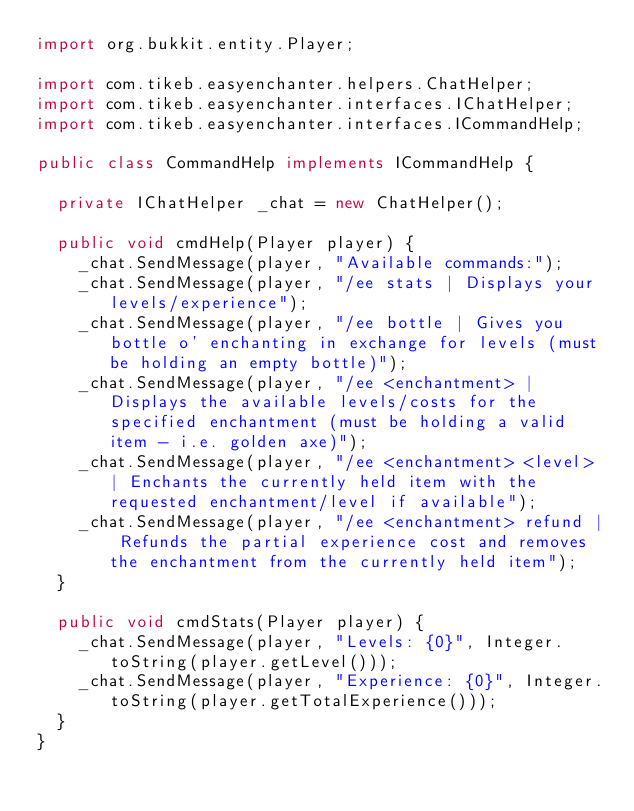<code> <loc_0><loc_0><loc_500><loc_500><_Java_>import org.bukkit.entity.Player;

import com.tikeb.easyenchanter.helpers.ChatHelper;
import com.tikeb.easyenchanter.interfaces.IChatHelper;
import com.tikeb.easyenchanter.interfaces.ICommandHelp;

public class CommandHelp implements ICommandHelp {

	private IChatHelper _chat = new ChatHelper();

	public void cmdHelp(Player player) {
		_chat.SendMessage(player, "Available commands:");
		_chat.SendMessage(player, "/ee stats | Displays your levels/experience");
		_chat.SendMessage(player, "/ee bottle | Gives you bottle o' enchanting in exchange for levels (must be holding an empty bottle)");
		_chat.SendMessage(player, "/ee <enchantment> | Displays the available levels/costs for the specified enchantment (must be holding a valid item - i.e. golden axe)");
		_chat.SendMessage(player, "/ee <enchantment> <level> | Enchants the currently held item with the requested enchantment/level if available");
		_chat.SendMessage(player, "/ee <enchantment> refund | Refunds the partial experience cost and removes the enchantment from the currently held item");
	}

	public void cmdStats(Player player) {
		_chat.SendMessage(player, "Levels: {0}", Integer.toString(player.getLevel()));
		_chat.SendMessage(player, "Experience: {0}", Integer.toString(player.getTotalExperience()));
	}
}</code> 